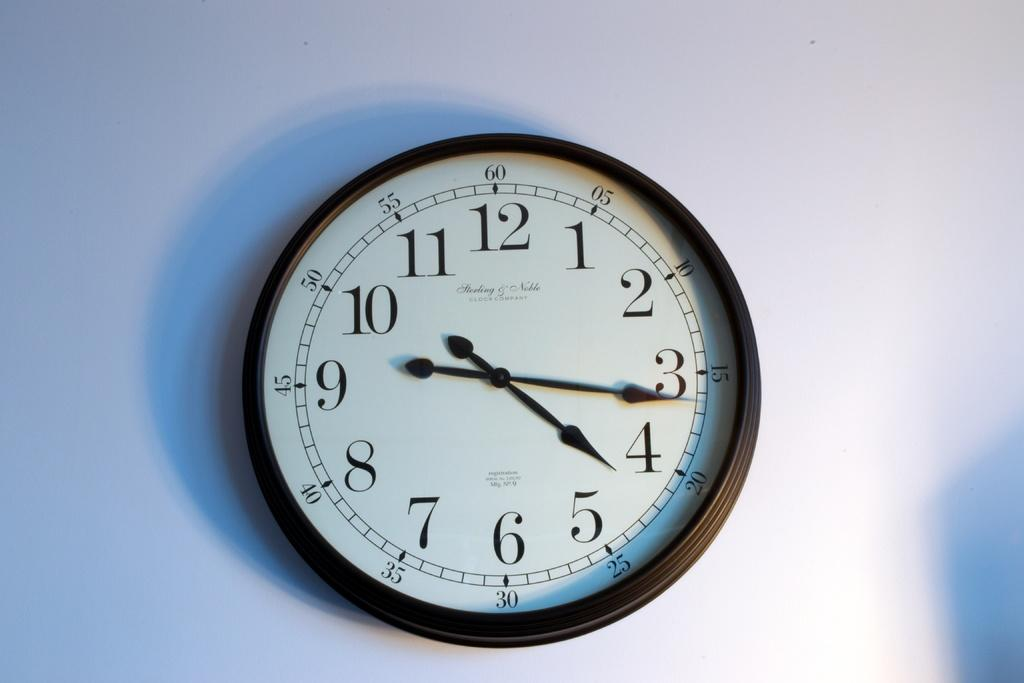<image>
Render a clear and concise summary of the photo. a clock mounted on the wall with the time if 4:16 